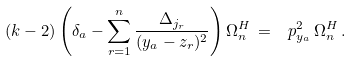Convert formula to latex. <formula><loc_0><loc_0><loc_500><loc_500>( k - 2 ) \left ( \delta _ { a } - \sum _ { r = 1 } ^ { n } \frac { \Delta _ { j _ { r } } } { ( y _ { a } - z _ { r } ) ^ { 2 } } \right ) \Omega ^ { H } _ { n } \, = \, \ p _ { y _ { a } } ^ { 2 } \, \Omega ^ { H } _ { n } \, .</formula> 